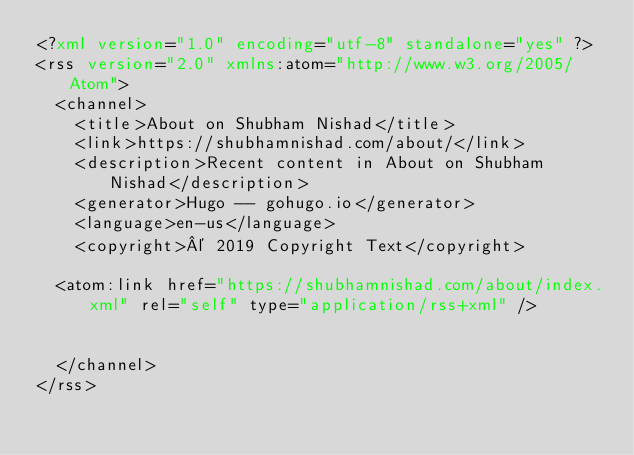Convert code to text. <code><loc_0><loc_0><loc_500><loc_500><_XML_><?xml version="1.0" encoding="utf-8" standalone="yes" ?>
<rss version="2.0" xmlns:atom="http://www.w3.org/2005/Atom">
  <channel>
    <title>About on Shubham Nishad</title>
    <link>https://shubhamnishad.com/about/</link>
    <description>Recent content in About on Shubham Nishad</description>
    <generator>Hugo -- gohugo.io</generator>
    <language>en-us</language>
    <copyright>© 2019 Copyright Text</copyright>
    
	<atom:link href="https://shubhamnishad.com/about/index.xml" rel="self" type="application/rss+xml" />
    
    
  </channel>
</rss></code> 